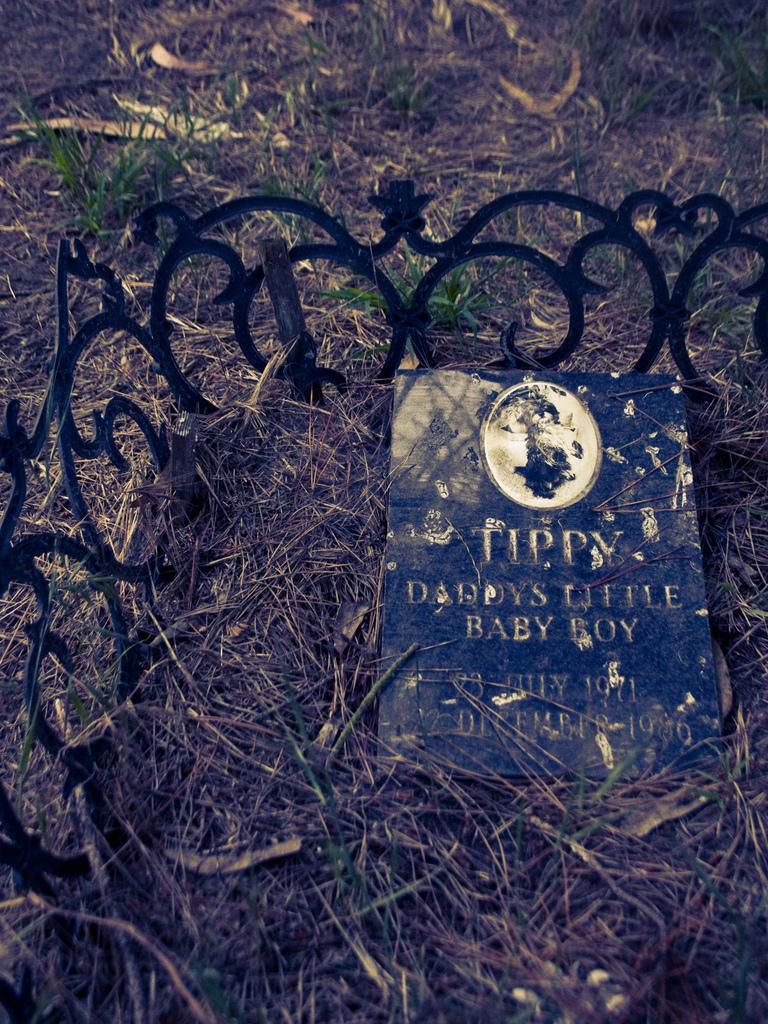What type of surface is visible at the bottom of the image? There is grass on the ground at the bottom of the image. What can be seen with text on it in the image? There is an object with text on it in the image. What type of structure is present in the image? There is a fencing with a design in the image. How many deer can be seen interacting with the fencing in the image? There are no deer present in the image; it only features grass, an object with text, and a fencing with a design. What type of connection does the owl have with the text on the object in the image? There is no owl present in the image, and therefore no connection can be established between the owl and the text on the object. 